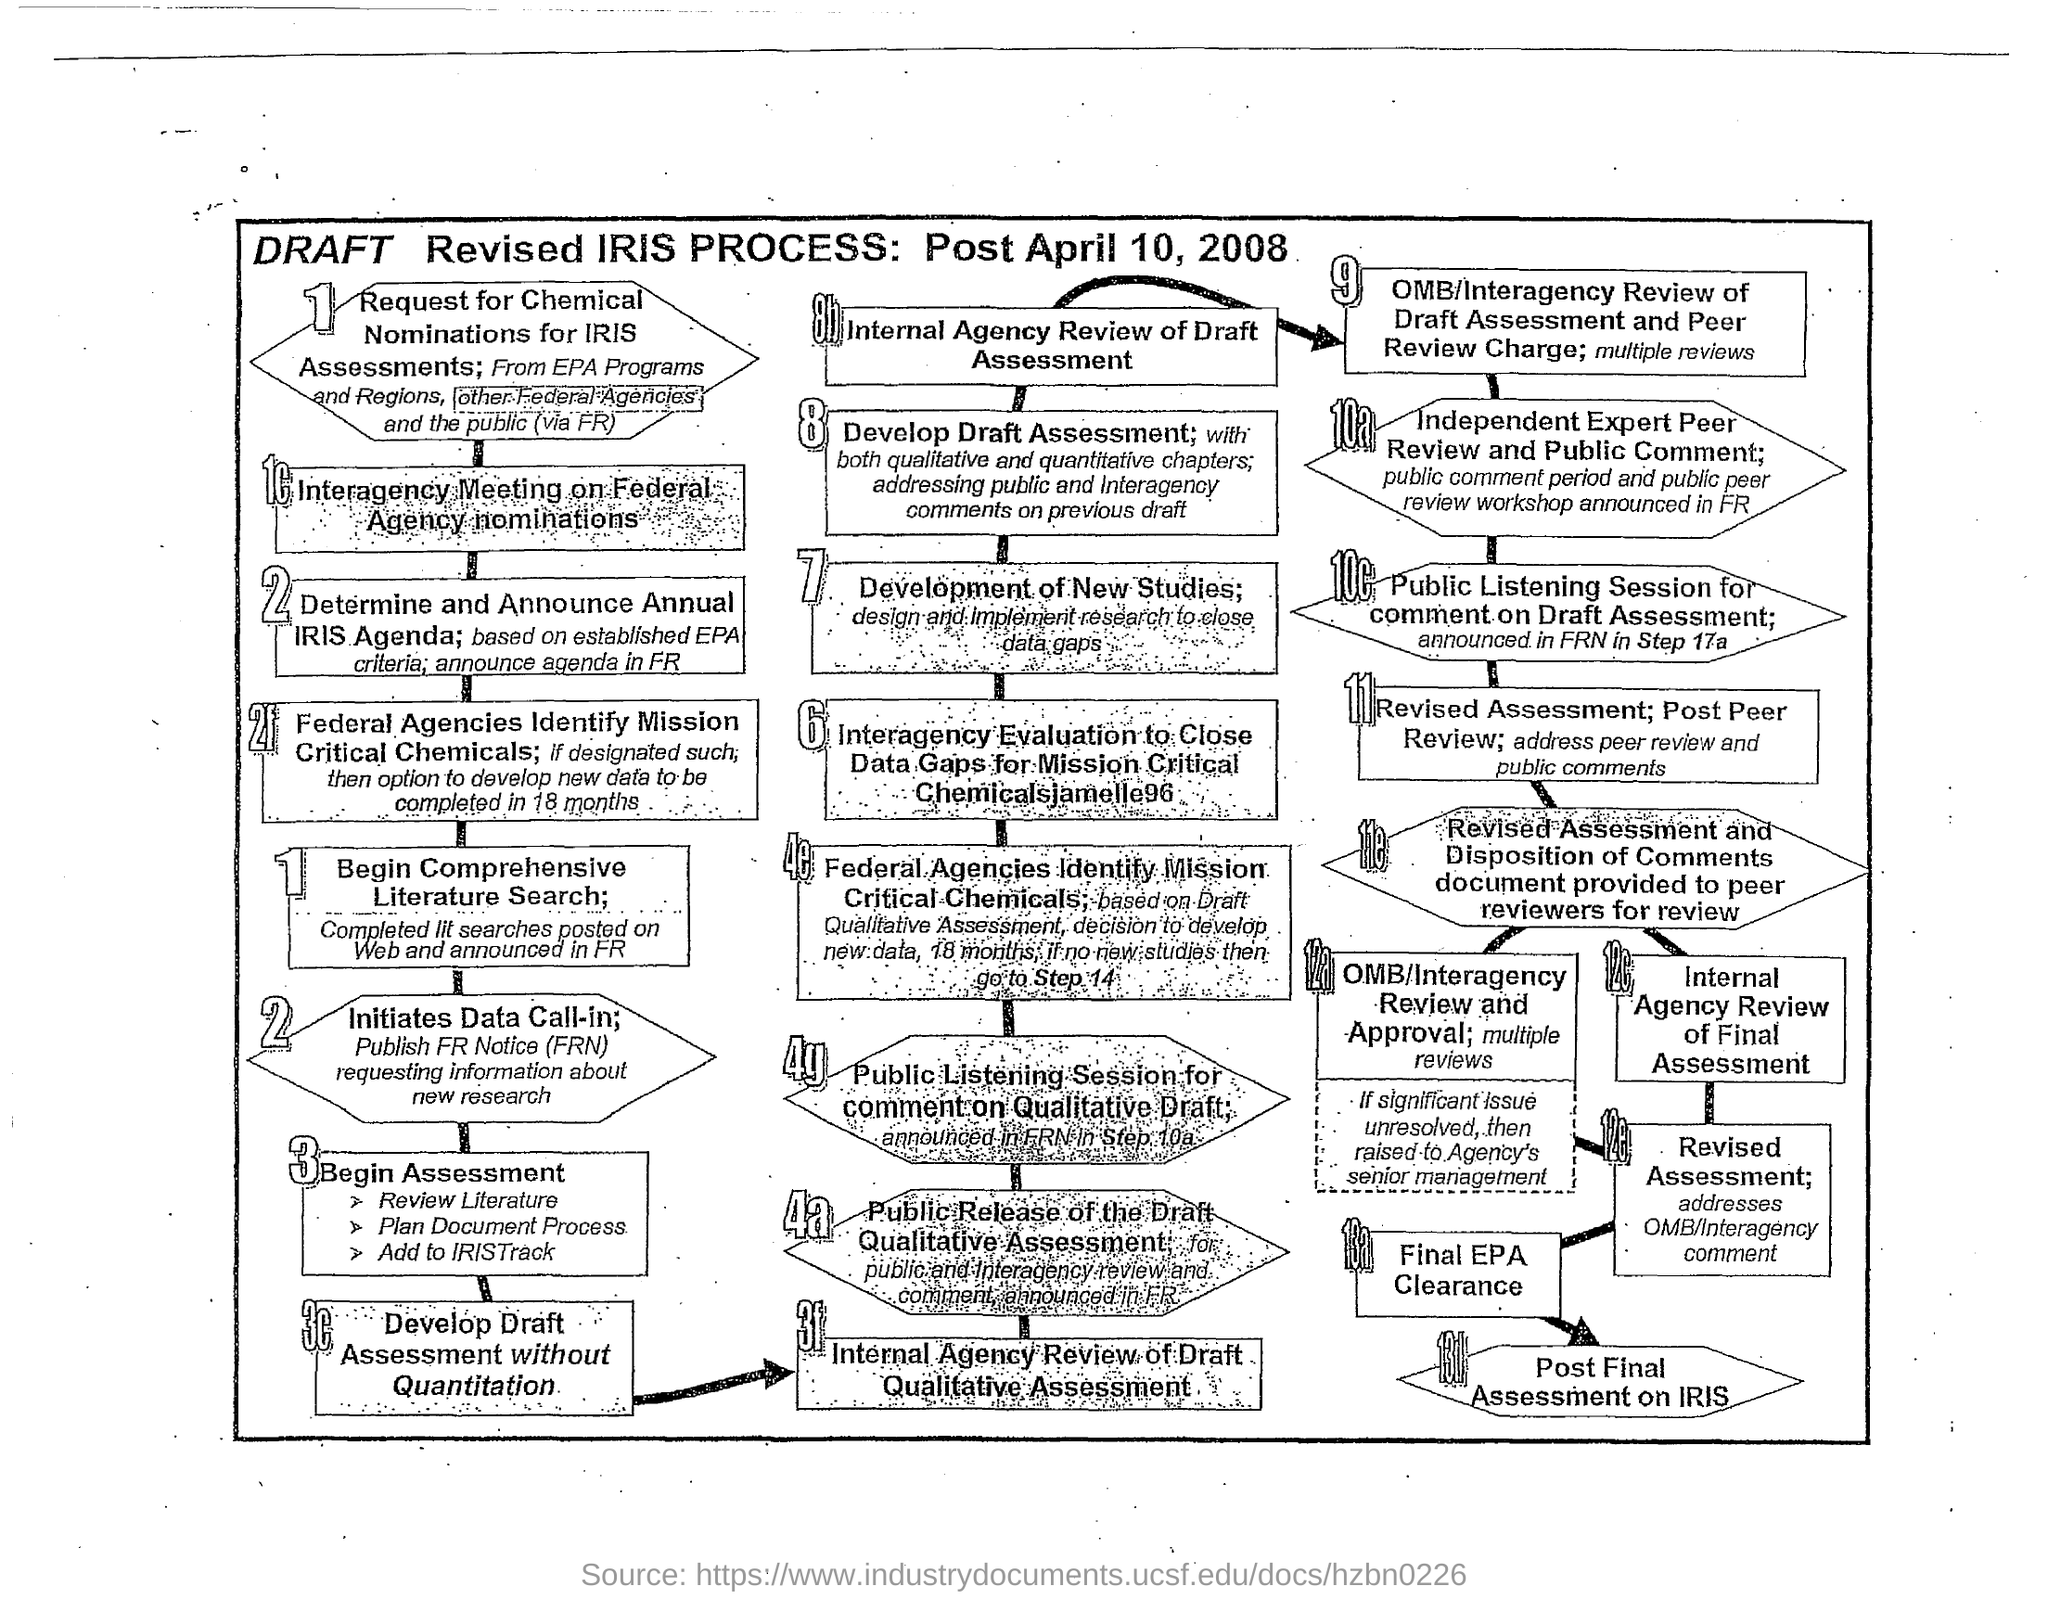What is the date mentioned?
Your answer should be very brief. Post April 10, 2008. What is the 7th step in the flowchart?
Your answer should be very brief. Development of New Studies; design and implement research to close data gaps. 